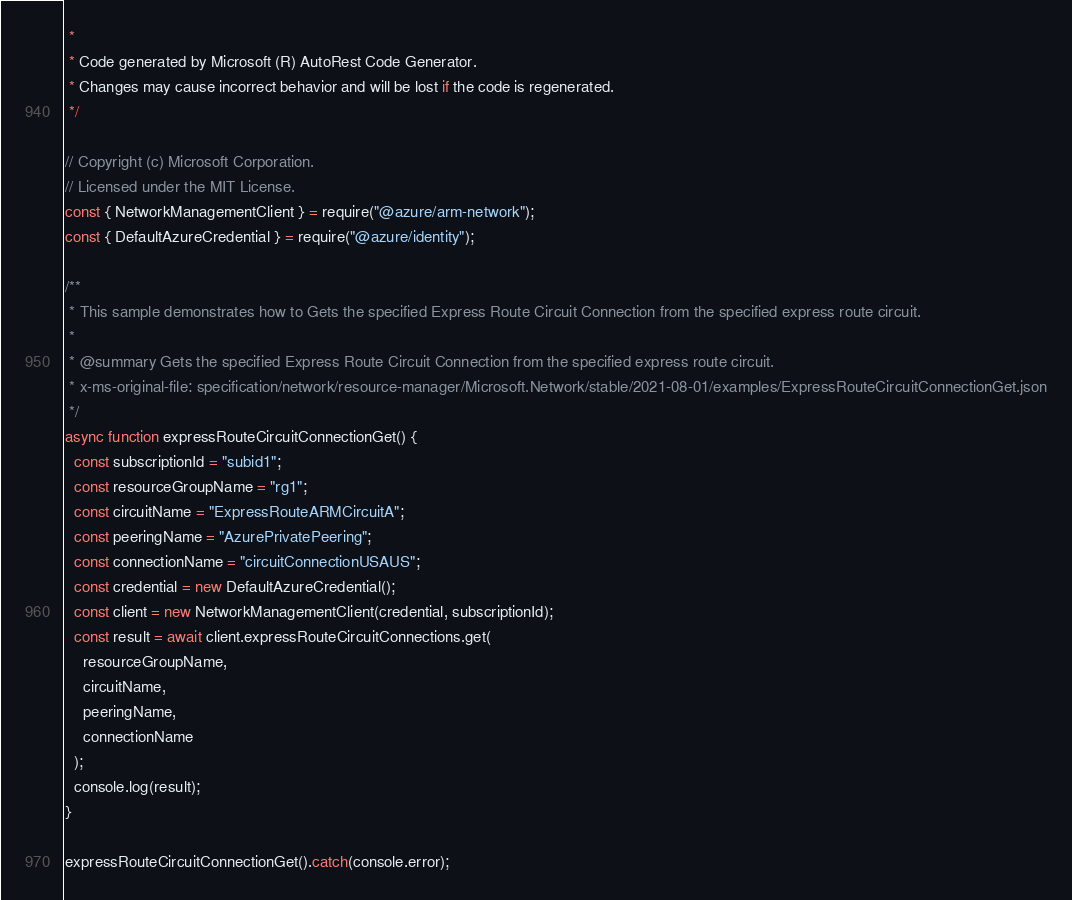Convert code to text. <code><loc_0><loc_0><loc_500><loc_500><_JavaScript_> *
 * Code generated by Microsoft (R) AutoRest Code Generator.
 * Changes may cause incorrect behavior and will be lost if the code is regenerated.
 */

// Copyright (c) Microsoft Corporation.
// Licensed under the MIT License.
const { NetworkManagementClient } = require("@azure/arm-network");
const { DefaultAzureCredential } = require("@azure/identity");

/**
 * This sample demonstrates how to Gets the specified Express Route Circuit Connection from the specified express route circuit.
 *
 * @summary Gets the specified Express Route Circuit Connection from the specified express route circuit.
 * x-ms-original-file: specification/network/resource-manager/Microsoft.Network/stable/2021-08-01/examples/ExpressRouteCircuitConnectionGet.json
 */
async function expressRouteCircuitConnectionGet() {
  const subscriptionId = "subid1";
  const resourceGroupName = "rg1";
  const circuitName = "ExpressRouteARMCircuitA";
  const peeringName = "AzurePrivatePeering";
  const connectionName = "circuitConnectionUSAUS";
  const credential = new DefaultAzureCredential();
  const client = new NetworkManagementClient(credential, subscriptionId);
  const result = await client.expressRouteCircuitConnections.get(
    resourceGroupName,
    circuitName,
    peeringName,
    connectionName
  );
  console.log(result);
}

expressRouteCircuitConnectionGet().catch(console.error);
</code> 